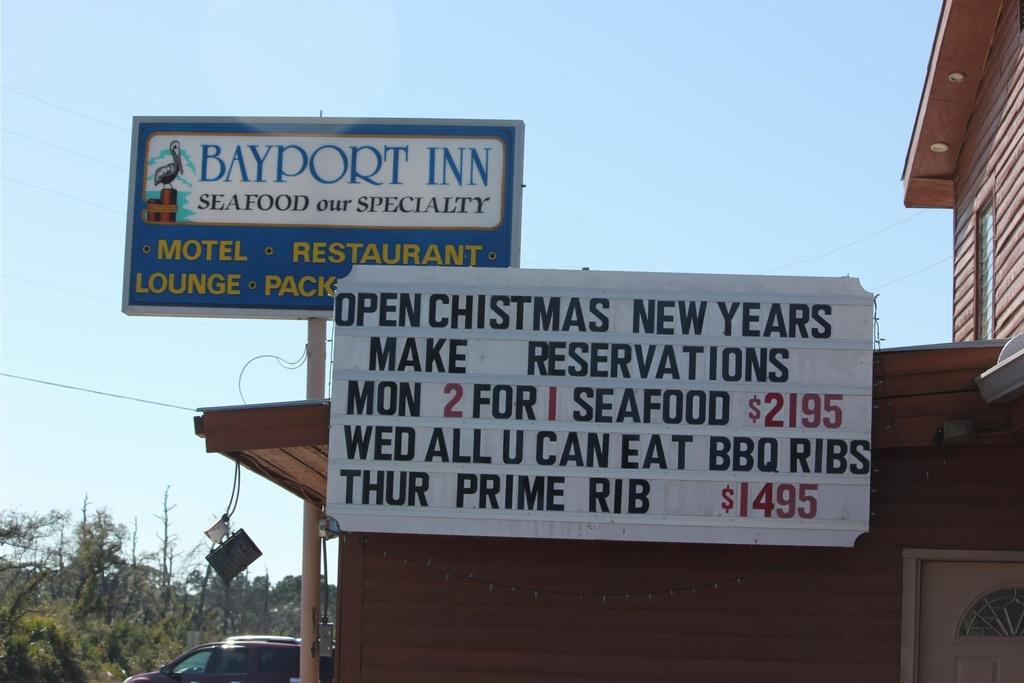What type of food is served on thursdays at this restaurant?
Your answer should be very brief. Prime rib. 